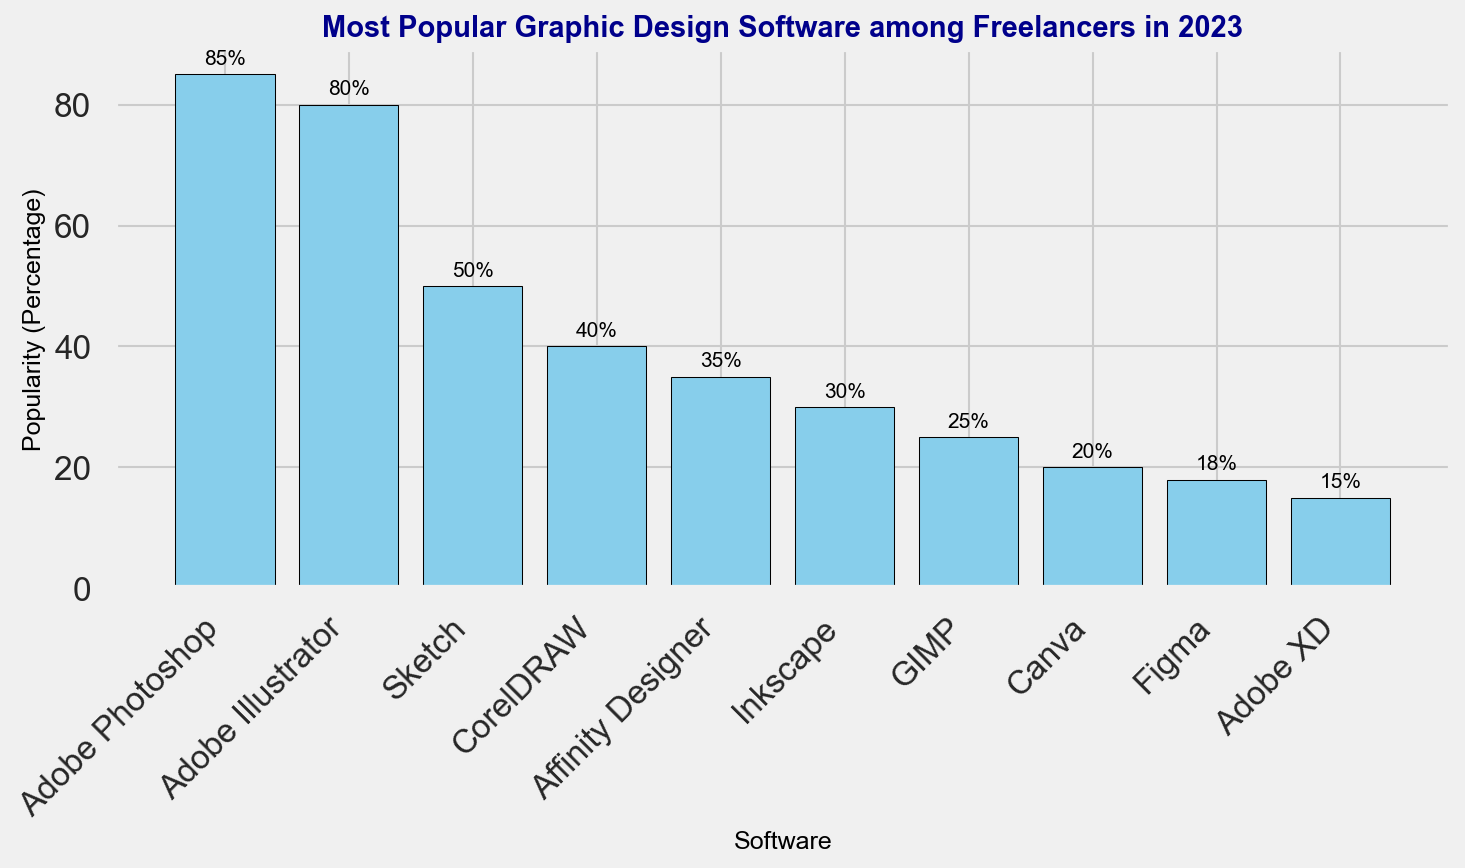what's the average popularity percentage of the top 3 most popular software? The top 3 most popular software are Adobe Photoshop (85%), Adobe Illustrator (80%), and Sketch (50%). Sum these percentages: 85 + 80 + 50 = 215. Divide by 3 to get the average: 215 / 3 ≈ 71.67
Answer: 71.67 Which software is more popular, Affinity Designer or CorelDRAW? Compare the popularity percentages: Affinity Designer (35%) and CorelDRAW (40%). CorelDRAW's percentage is higher.
Answer: CorelDRAW Among Adobe products listed, which one is the least popular? The Adobe products listed are Adobe Photoshop (85%), Adobe Illustrator (80%), and Adobe XD (15%). The least popular among them is Adobe XD with 15%.
Answer: Adobe XD What's the difference in popularity percentage between Inkscape and GIMP? Inkscape has a popularity percentage of 30% and GIMP has 25%. Subtract GIMP's percentage from Inkscape's: 30 - 25 = 5
Answer: 5 If you sum the popularity percentages of Canva and Figma, how much will it be? Canva has a popularity percentage of 20% and Figma has 18%. Sum these percentages: 20 + 18 = 38
Answer: 38 What software's popularity percentage is exactly half of Adobe Photoshop's? Adobe Photoshop has a popularity percentage of 85%. Half of 85 is 42.5. The closest software to this value is CorelDRAW with 40%.
Answer: CorelDRAW Which software is just above Adobe XD in popularity percentage? Adobe XD has a popularity percentage of 15%. The software just above it is Figma with 18%.
Answer: Figma What's the combined popularity percentage of all graphic design software in the chart? Sum the popularity percentages: 85 + 80 + 50 + 40 + 35 + 30 + 25 + 20 + 18 + 15 = 398
Answer: 398 Are there more software with a popularity percentage greater than 30% or less than 30%? Greater than 30%: Adobe Photoshop, Adobe Illustrator, Sketch, CorelDRAW, Affinity Designer (5 software). Less than 30%: Inkscape, GIMP, Canva, Figma, Adobe XD (5 software). There are equal numbers in both categories.
Answer: Equal 